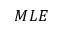Convert formula to latex. <formula><loc_0><loc_0><loc_500><loc_500>M L E</formula> 